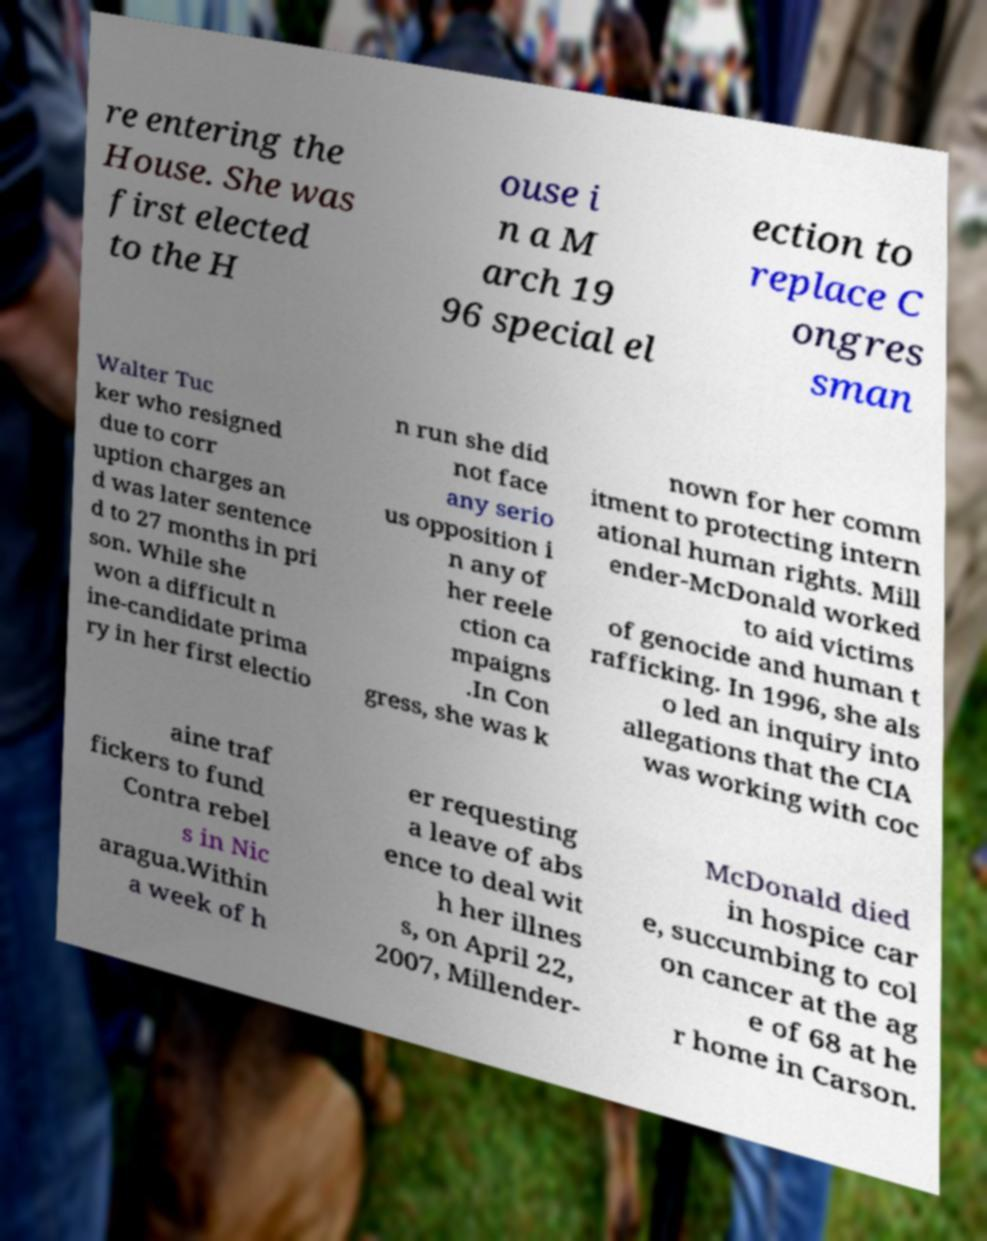I need the written content from this picture converted into text. Can you do that? re entering the House. She was first elected to the H ouse i n a M arch 19 96 special el ection to replace C ongres sman Walter Tuc ker who resigned due to corr uption charges an d was later sentence d to 27 months in pri son. While she won a difficult n ine-candidate prima ry in her first electio n run she did not face any serio us opposition i n any of her reele ction ca mpaigns .In Con gress, she was k nown for her comm itment to protecting intern ational human rights. Mill ender-McDonald worked to aid victims of genocide and human t rafficking. In 1996, she als o led an inquiry into allegations that the CIA was working with coc aine traf fickers to fund Contra rebel s in Nic aragua.Within a week of h er requesting a leave of abs ence to deal wit h her illnes s, on April 22, 2007, Millender- McDonald died in hospice car e, succumbing to col on cancer at the ag e of 68 at he r home in Carson. 